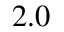Convert formula to latex. <formula><loc_0><loc_0><loc_500><loc_500>2 . 0</formula> 